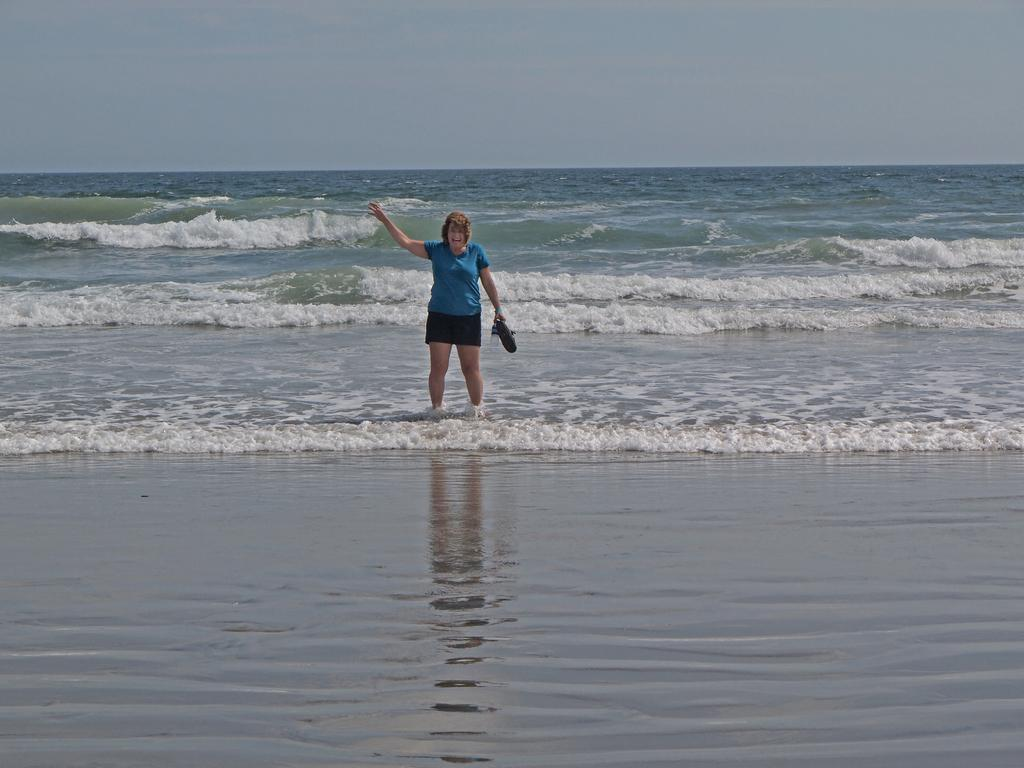Who is present in the image? There is a woman in the image. What is the woman's location in the image? The woman is standing near the sea. What is the woman wearing in the image? The woman is wearing a blue t-shirt and black shorts. What can be seen at the top of the image? The sky is visible at the top of the image. What type of cushion is the woman sitting on in the image? There is no cushion present in the image; the woman is standing near the sea. 